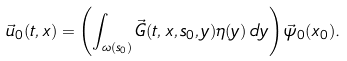<formula> <loc_0><loc_0><loc_500><loc_500>\vec { u } _ { 0 } ( t , x ) = \left ( \int _ { \omega ( s _ { 0 } ) } \vec { G } ( t , x , s _ { 0 } , y ) \eta ( y ) \, d y \right ) \vec { \psi } _ { 0 } ( x _ { 0 } ) .</formula> 